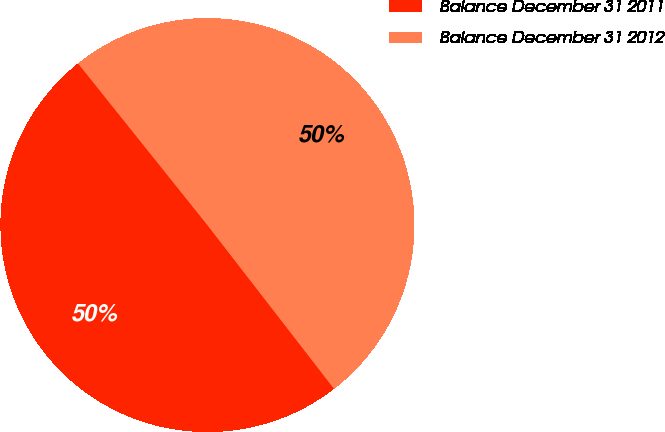Convert chart. <chart><loc_0><loc_0><loc_500><loc_500><pie_chart><fcel>Balance December 31 2011<fcel>Balance December 31 2012<nl><fcel>49.74%<fcel>50.26%<nl></chart> 